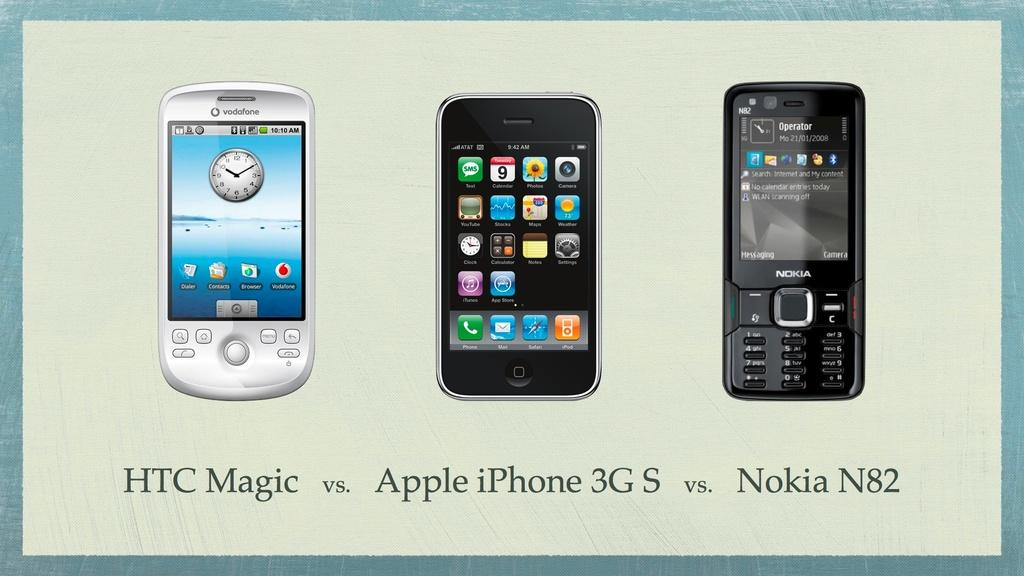<image>
Share a concise interpretation of the image provided. An ad compares an HTC, an Iphone, and a Nokia. 